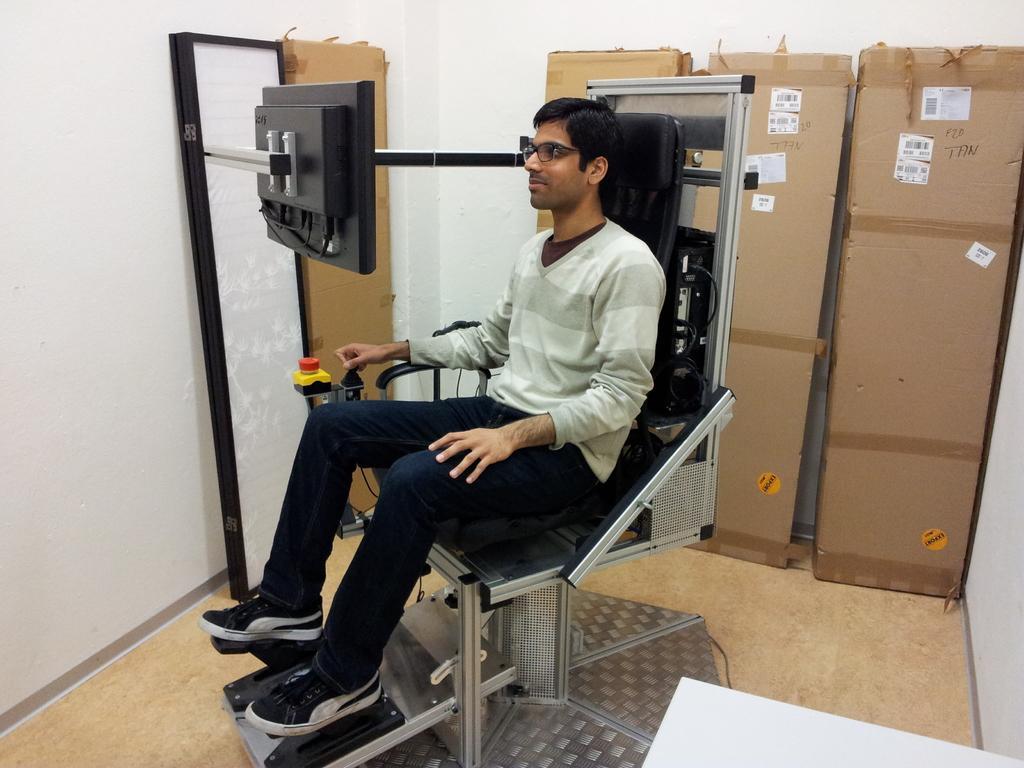Can you describe this image briefly? In this image we can see a person sitting on the chair, there is a screen in front of the person, there are few boxes and a board near the wall. 